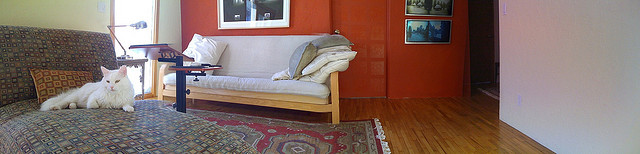Is the space in the image used for any specific activities? The space appears designed for relaxation and social activities. The sofa provides a place to sit and unwind, perhaps while reading a book or watching TV, and the coffee table suggests a spot for beverages or snacks during a casual get-together. Does the space feature any decorations or personal items? Yes, there are paintings hung on the red wall, which add a personal touch and artistic flair to the room. The presence of such items indicates a personal space that reflects the tastes and interests of the inhabitants. 